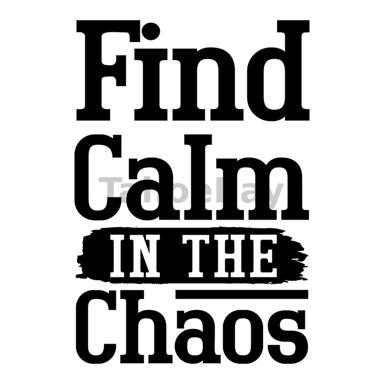What is the text on the image suggesting? The text "Find Calm IN THE Chaos" suggests the idea of finding peace and tranquility amidst disorder and stress in our lives. It encourages people to search for a sense of balance and calmness even when things get hectic or tangled. 